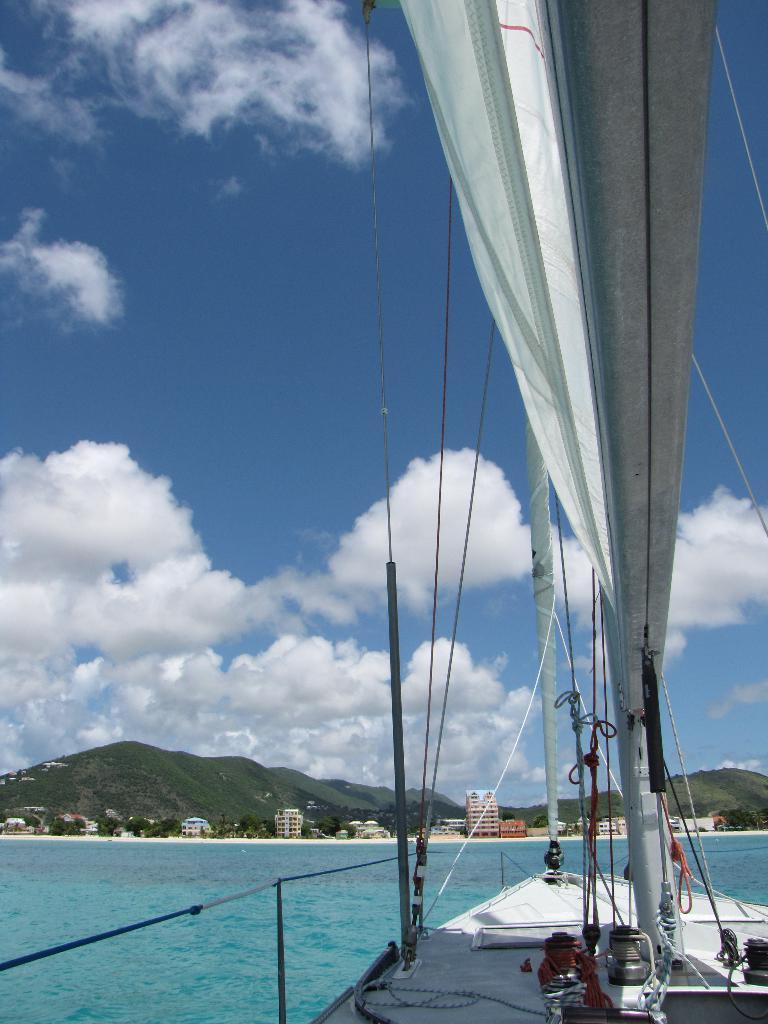What is the main subject of the image? The main subject of the image is a boat. Where is the boat located? The boat is on the water. What can be seen in the background of the image? Mountains and the sky are visible in the background of the image. What type of pain is the boat experiencing in the image? The boat is not experiencing any pain in the image, as it is an inanimate object. 